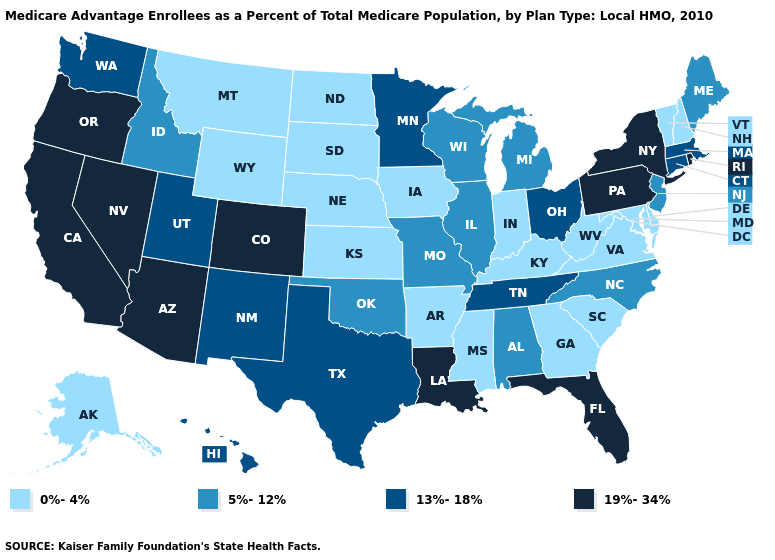Which states have the highest value in the USA?
Answer briefly. Arizona, California, Colorado, Florida, Louisiana, Nevada, New York, Oregon, Pennsylvania, Rhode Island. What is the highest value in states that border Florida?
Quick response, please. 5%-12%. Which states have the lowest value in the USA?
Keep it brief. Alaska, Arkansas, Delaware, Georgia, Iowa, Indiana, Kansas, Kentucky, Maryland, Mississippi, Montana, North Dakota, Nebraska, New Hampshire, South Carolina, South Dakota, Virginia, Vermont, West Virginia, Wyoming. Among the states that border Arkansas , does Louisiana have the highest value?
Be succinct. Yes. Name the states that have a value in the range 19%-34%?
Give a very brief answer. Arizona, California, Colorado, Florida, Louisiana, Nevada, New York, Oregon, Pennsylvania, Rhode Island. What is the value of Kentucky?
Concise answer only. 0%-4%. What is the value of Louisiana?
Write a very short answer. 19%-34%. Name the states that have a value in the range 13%-18%?
Be succinct. Connecticut, Hawaii, Massachusetts, Minnesota, New Mexico, Ohio, Tennessee, Texas, Utah, Washington. How many symbols are there in the legend?
Concise answer only. 4. Name the states that have a value in the range 13%-18%?
Quick response, please. Connecticut, Hawaii, Massachusetts, Minnesota, New Mexico, Ohio, Tennessee, Texas, Utah, Washington. How many symbols are there in the legend?
Short answer required. 4. What is the highest value in states that border Louisiana?
Short answer required. 13%-18%. Among the states that border Nebraska , which have the lowest value?
Short answer required. Iowa, Kansas, South Dakota, Wyoming. What is the value of Nebraska?
Write a very short answer. 0%-4%. Among the states that border New York , does Massachusetts have the lowest value?
Keep it brief. No. 